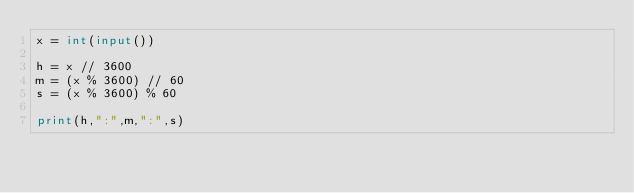<code> <loc_0><loc_0><loc_500><loc_500><_Python_>x = int(input())

h = x // 3600
m = (x % 3600) // 60
s = (x % 3600) % 60

print(h,":",m,":",s)
</code> 